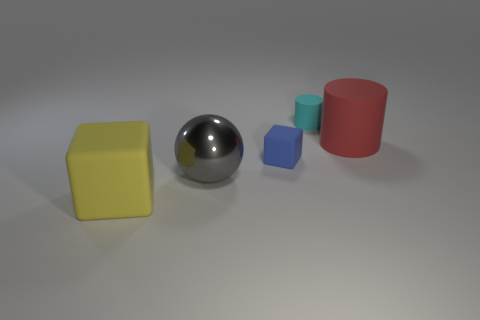Add 2 large cubes. How many objects exist? 7 Subtract 0 gray blocks. How many objects are left? 5 Subtract all balls. How many objects are left? 4 Subtract all gray cubes. Subtract all green spheres. How many cubes are left? 2 Subtract all green balls. How many blue blocks are left? 1 Subtract all large rubber cylinders. Subtract all large rubber cylinders. How many objects are left? 3 Add 1 small cylinders. How many small cylinders are left? 2 Add 4 rubber blocks. How many rubber blocks exist? 6 